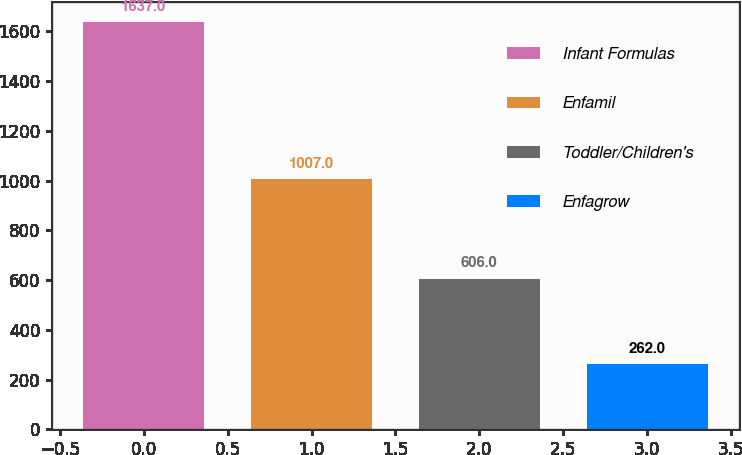Convert chart. <chart><loc_0><loc_0><loc_500><loc_500><bar_chart><fcel>Infant Formulas<fcel>Enfamil<fcel>Toddler/Children's<fcel>Enfagrow<nl><fcel>1637<fcel>1007<fcel>606<fcel>262<nl></chart> 